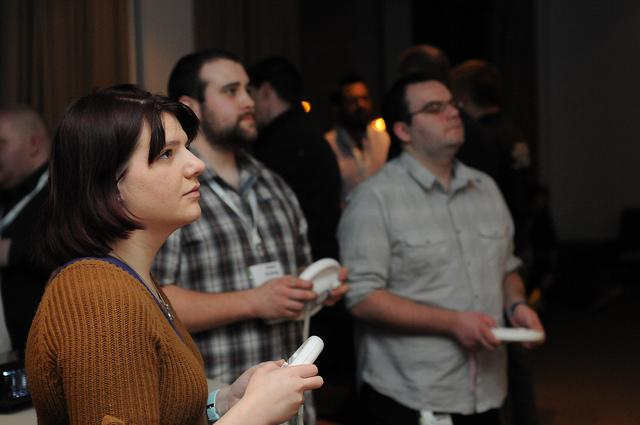What part of a car is symbolized in the objects they are holding?

Choices:
A) seatbelt
B) radio
C) steering wheel
D) headlights steering wheel 